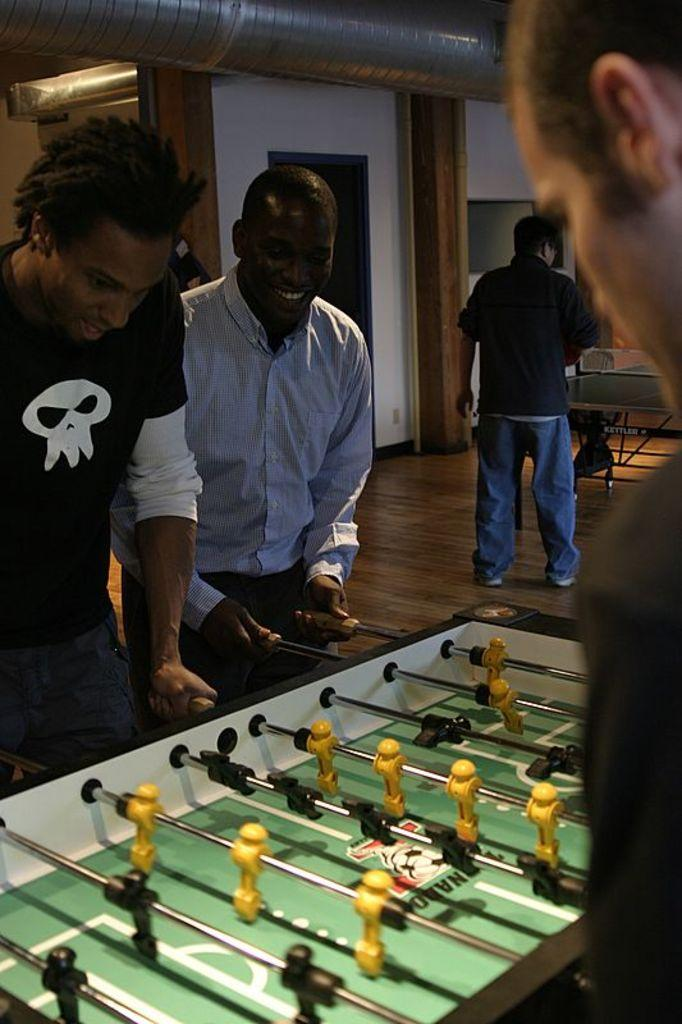How many people are in the image? There are persons standing in the image. What are they doing in the image? They are playing an indoor game. Can you identify any specific game being played? One person is playing table tennis. What type of surface is visible in the image? There is a floor in the image. Is there any entrance or exit visible in the image? Yes, there is a door in the image. What type of vest is the person wearing while playing table tennis in the image? There is no information about a vest in the image, as the focus is on the people playing an indoor game and the specific game being table tennis. 